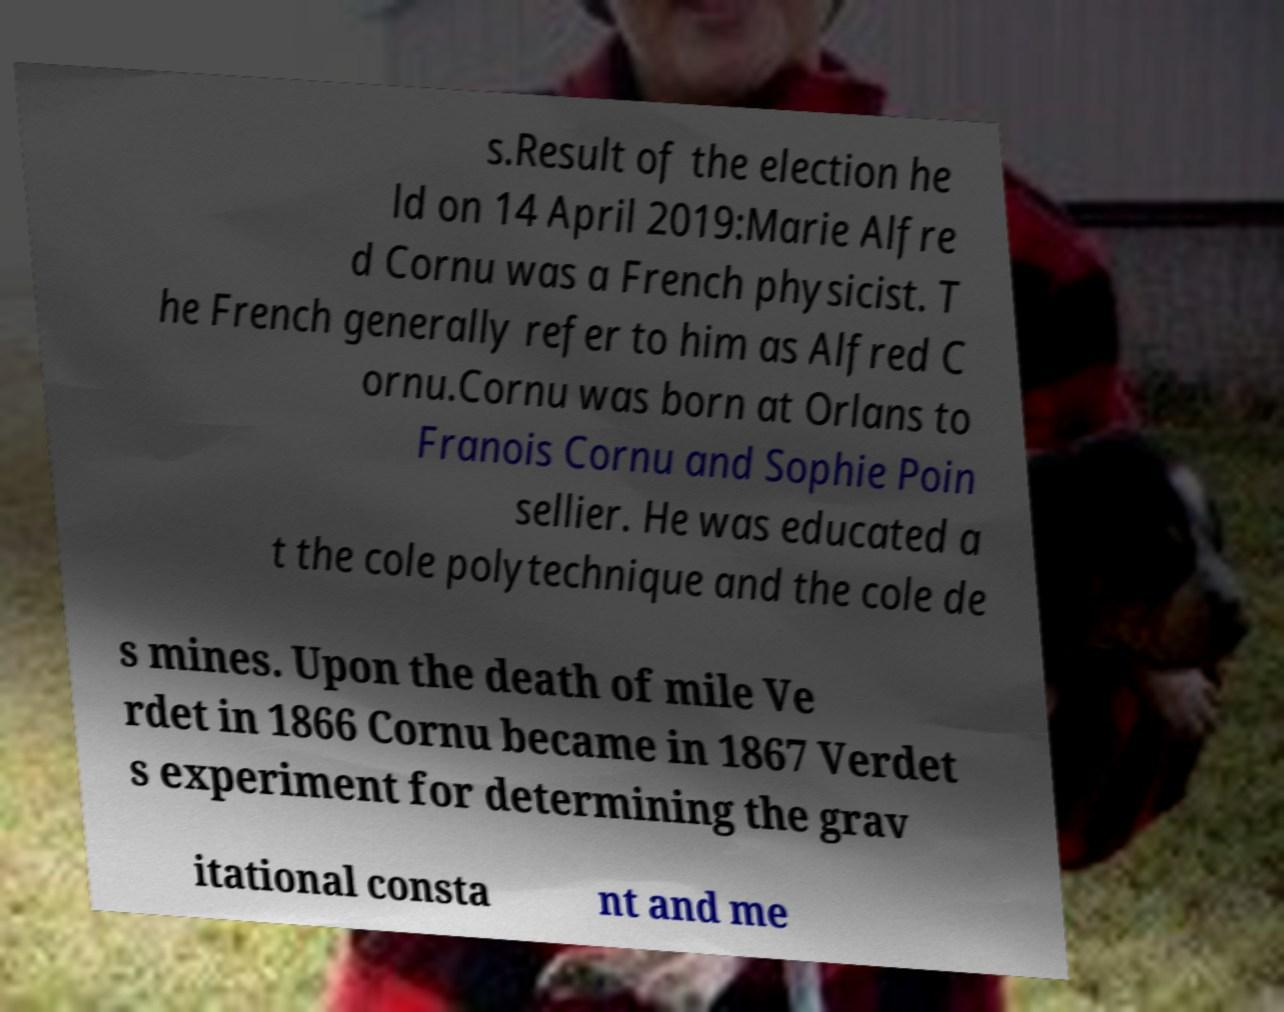There's text embedded in this image that I need extracted. Can you transcribe it verbatim? s.Result of the election he ld on 14 April 2019:Marie Alfre d Cornu was a French physicist. T he French generally refer to him as Alfred C ornu.Cornu was born at Orlans to Franois Cornu and Sophie Poin sellier. He was educated a t the cole polytechnique and the cole de s mines. Upon the death of mile Ve rdet in 1866 Cornu became in 1867 Verdet s experiment for determining the grav itational consta nt and me 